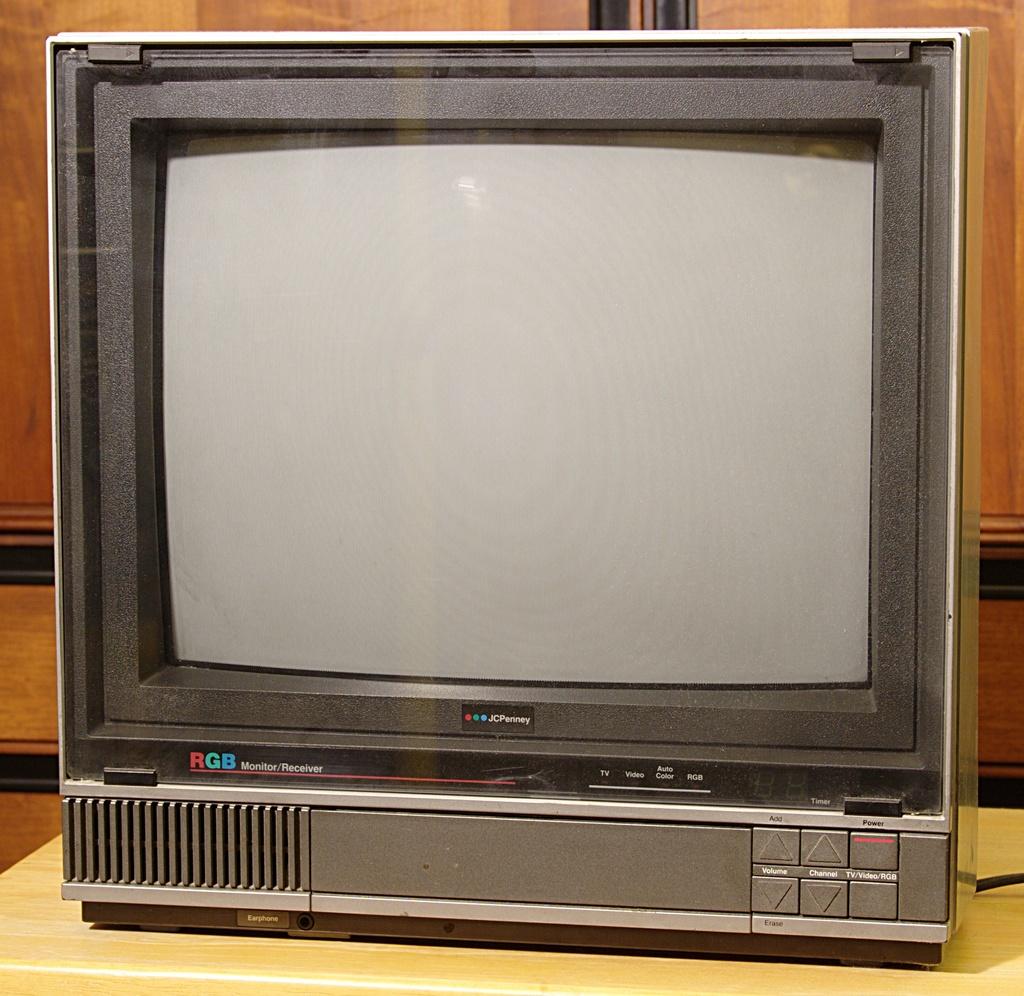What brand is this tv?
Your response must be concise. Rgb. 